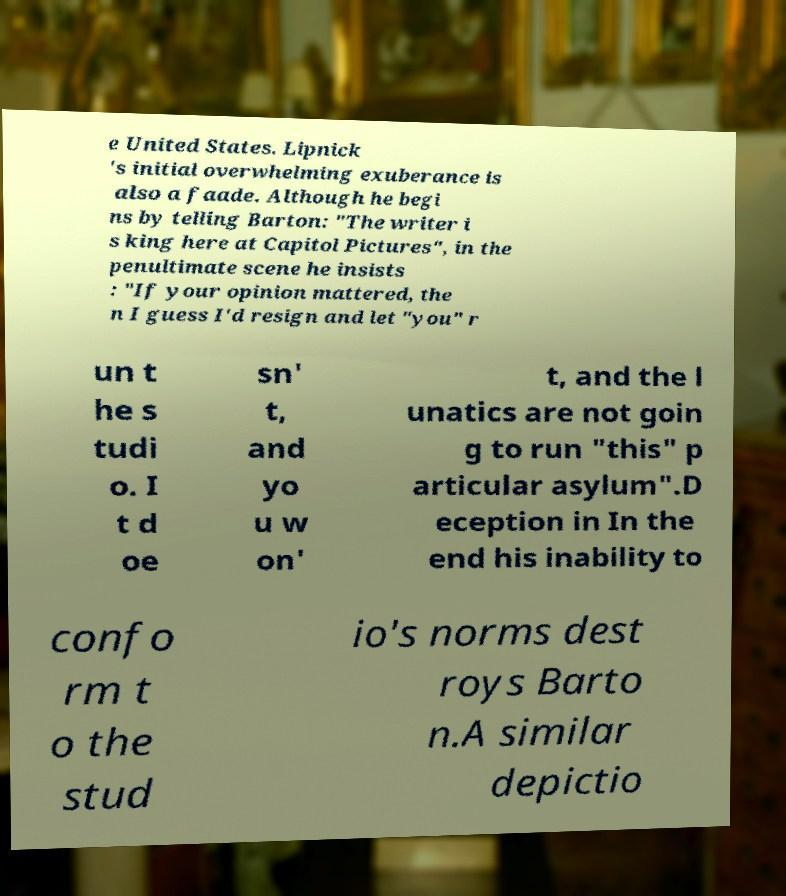Could you assist in decoding the text presented in this image and type it out clearly? e United States. Lipnick 's initial overwhelming exuberance is also a faade. Although he begi ns by telling Barton: "The writer i s king here at Capitol Pictures", in the penultimate scene he insists : "If your opinion mattered, the n I guess I'd resign and let "you" r un t he s tudi o. I t d oe sn' t, and yo u w on' t, and the l unatics are not goin g to run "this" p articular asylum".D eception in In the end his inability to confo rm t o the stud io's norms dest roys Barto n.A similar depictio 